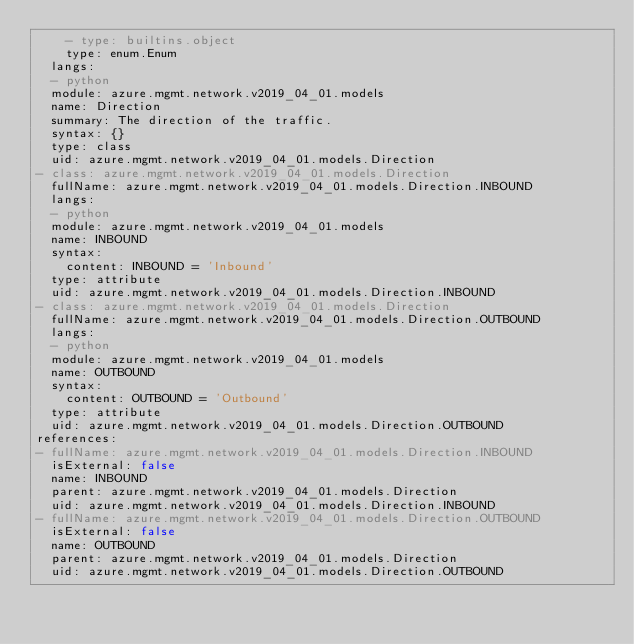<code> <loc_0><loc_0><loc_500><loc_500><_YAML_>    - type: builtins.object
    type: enum.Enum
  langs:
  - python
  module: azure.mgmt.network.v2019_04_01.models
  name: Direction
  summary: The direction of the traffic.
  syntax: {}
  type: class
  uid: azure.mgmt.network.v2019_04_01.models.Direction
- class: azure.mgmt.network.v2019_04_01.models.Direction
  fullName: azure.mgmt.network.v2019_04_01.models.Direction.INBOUND
  langs:
  - python
  module: azure.mgmt.network.v2019_04_01.models
  name: INBOUND
  syntax:
    content: INBOUND = 'Inbound'
  type: attribute
  uid: azure.mgmt.network.v2019_04_01.models.Direction.INBOUND
- class: azure.mgmt.network.v2019_04_01.models.Direction
  fullName: azure.mgmt.network.v2019_04_01.models.Direction.OUTBOUND
  langs:
  - python
  module: azure.mgmt.network.v2019_04_01.models
  name: OUTBOUND
  syntax:
    content: OUTBOUND = 'Outbound'
  type: attribute
  uid: azure.mgmt.network.v2019_04_01.models.Direction.OUTBOUND
references:
- fullName: azure.mgmt.network.v2019_04_01.models.Direction.INBOUND
  isExternal: false
  name: INBOUND
  parent: azure.mgmt.network.v2019_04_01.models.Direction
  uid: azure.mgmt.network.v2019_04_01.models.Direction.INBOUND
- fullName: azure.mgmt.network.v2019_04_01.models.Direction.OUTBOUND
  isExternal: false
  name: OUTBOUND
  parent: azure.mgmt.network.v2019_04_01.models.Direction
  uid: azure.mgmt.network.v2019_04_01.models.Direction.OUTBOUND
</code> 